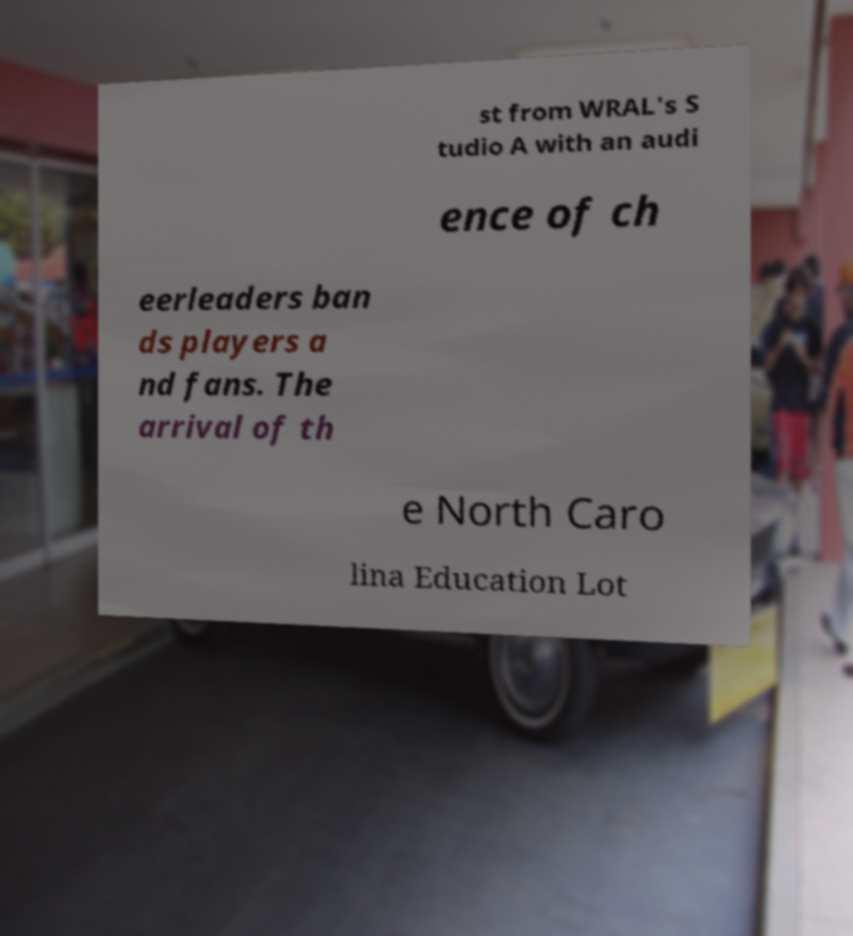Could you extract and type out the text from this image? st from WRAL's S tudio A with an audi ence of ch eerleaders ban ds players a nd fans. The arrival of th e North Caro lina Education Lot 